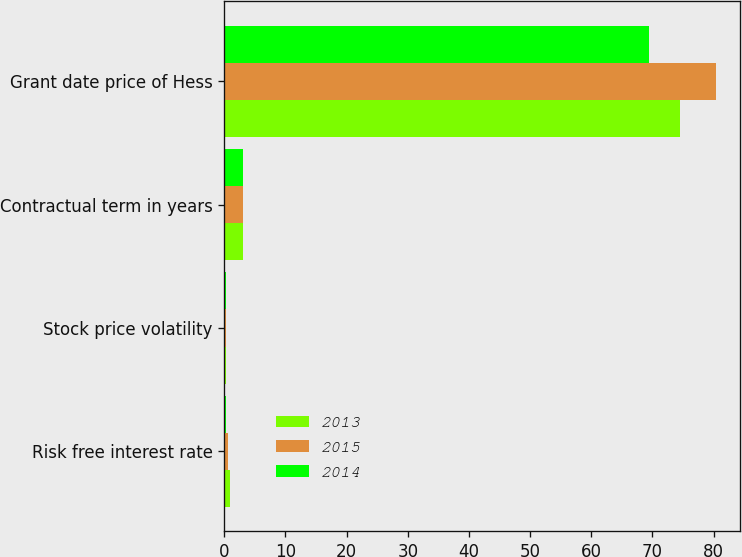Convert chart. <chart><loc_0><loc_0><loc_500><loc_500><stacked_bar_chart><ecel><fcel>Risk free interest rate<fcel>Stock price volatility<fcel>Contractual term in years<fcel>Grant date price of Hess<nl><fcel>2013<fcel>1.02<fcel>0.27<fcel>3<fcel>74.49<nl><fcel>2015<fcel>0.65<fcel>0.36<fcel>3<fcel>80.35<nl><fcel>2014<fcel>0.36<fcel>0.36<fcel>3<fcel>69.49<nl></chart> 